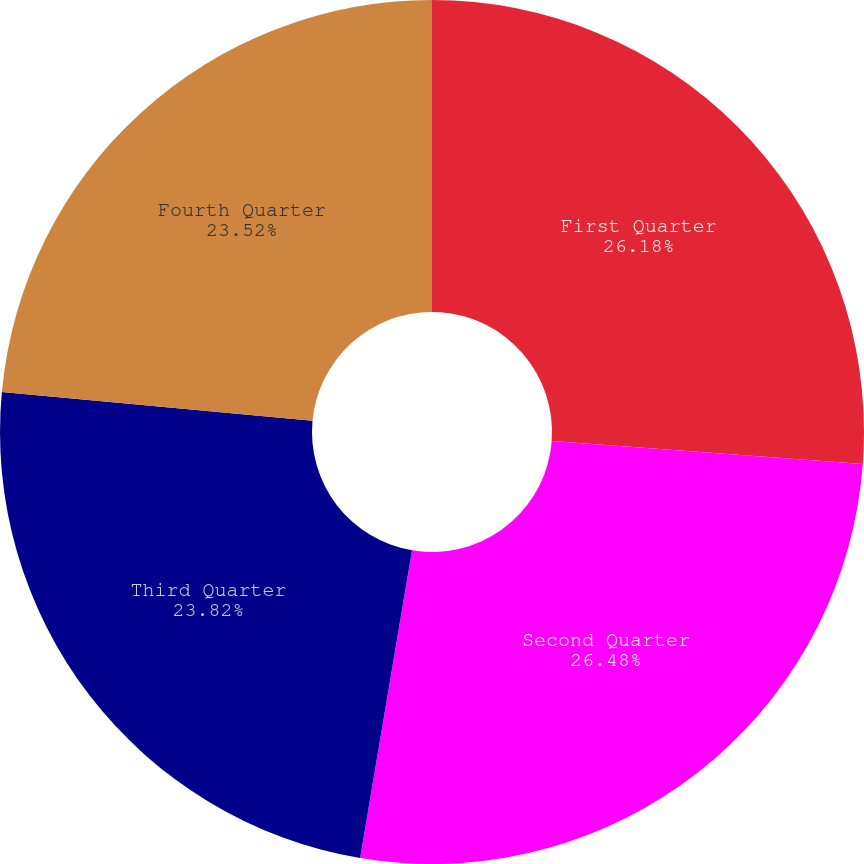Convert chart to OTSL. <chart><loc_0><loc_0><loc_500><loc_500><pie_chart><fcel>First Quarter<fcel>Second Quarter<fcel>Third Quarter<fcel>Fourth Quarter<nl><fcel>26.18%<fcel>26.48%<fcel>23.82%<fcel>23.52%<nl></chart> 